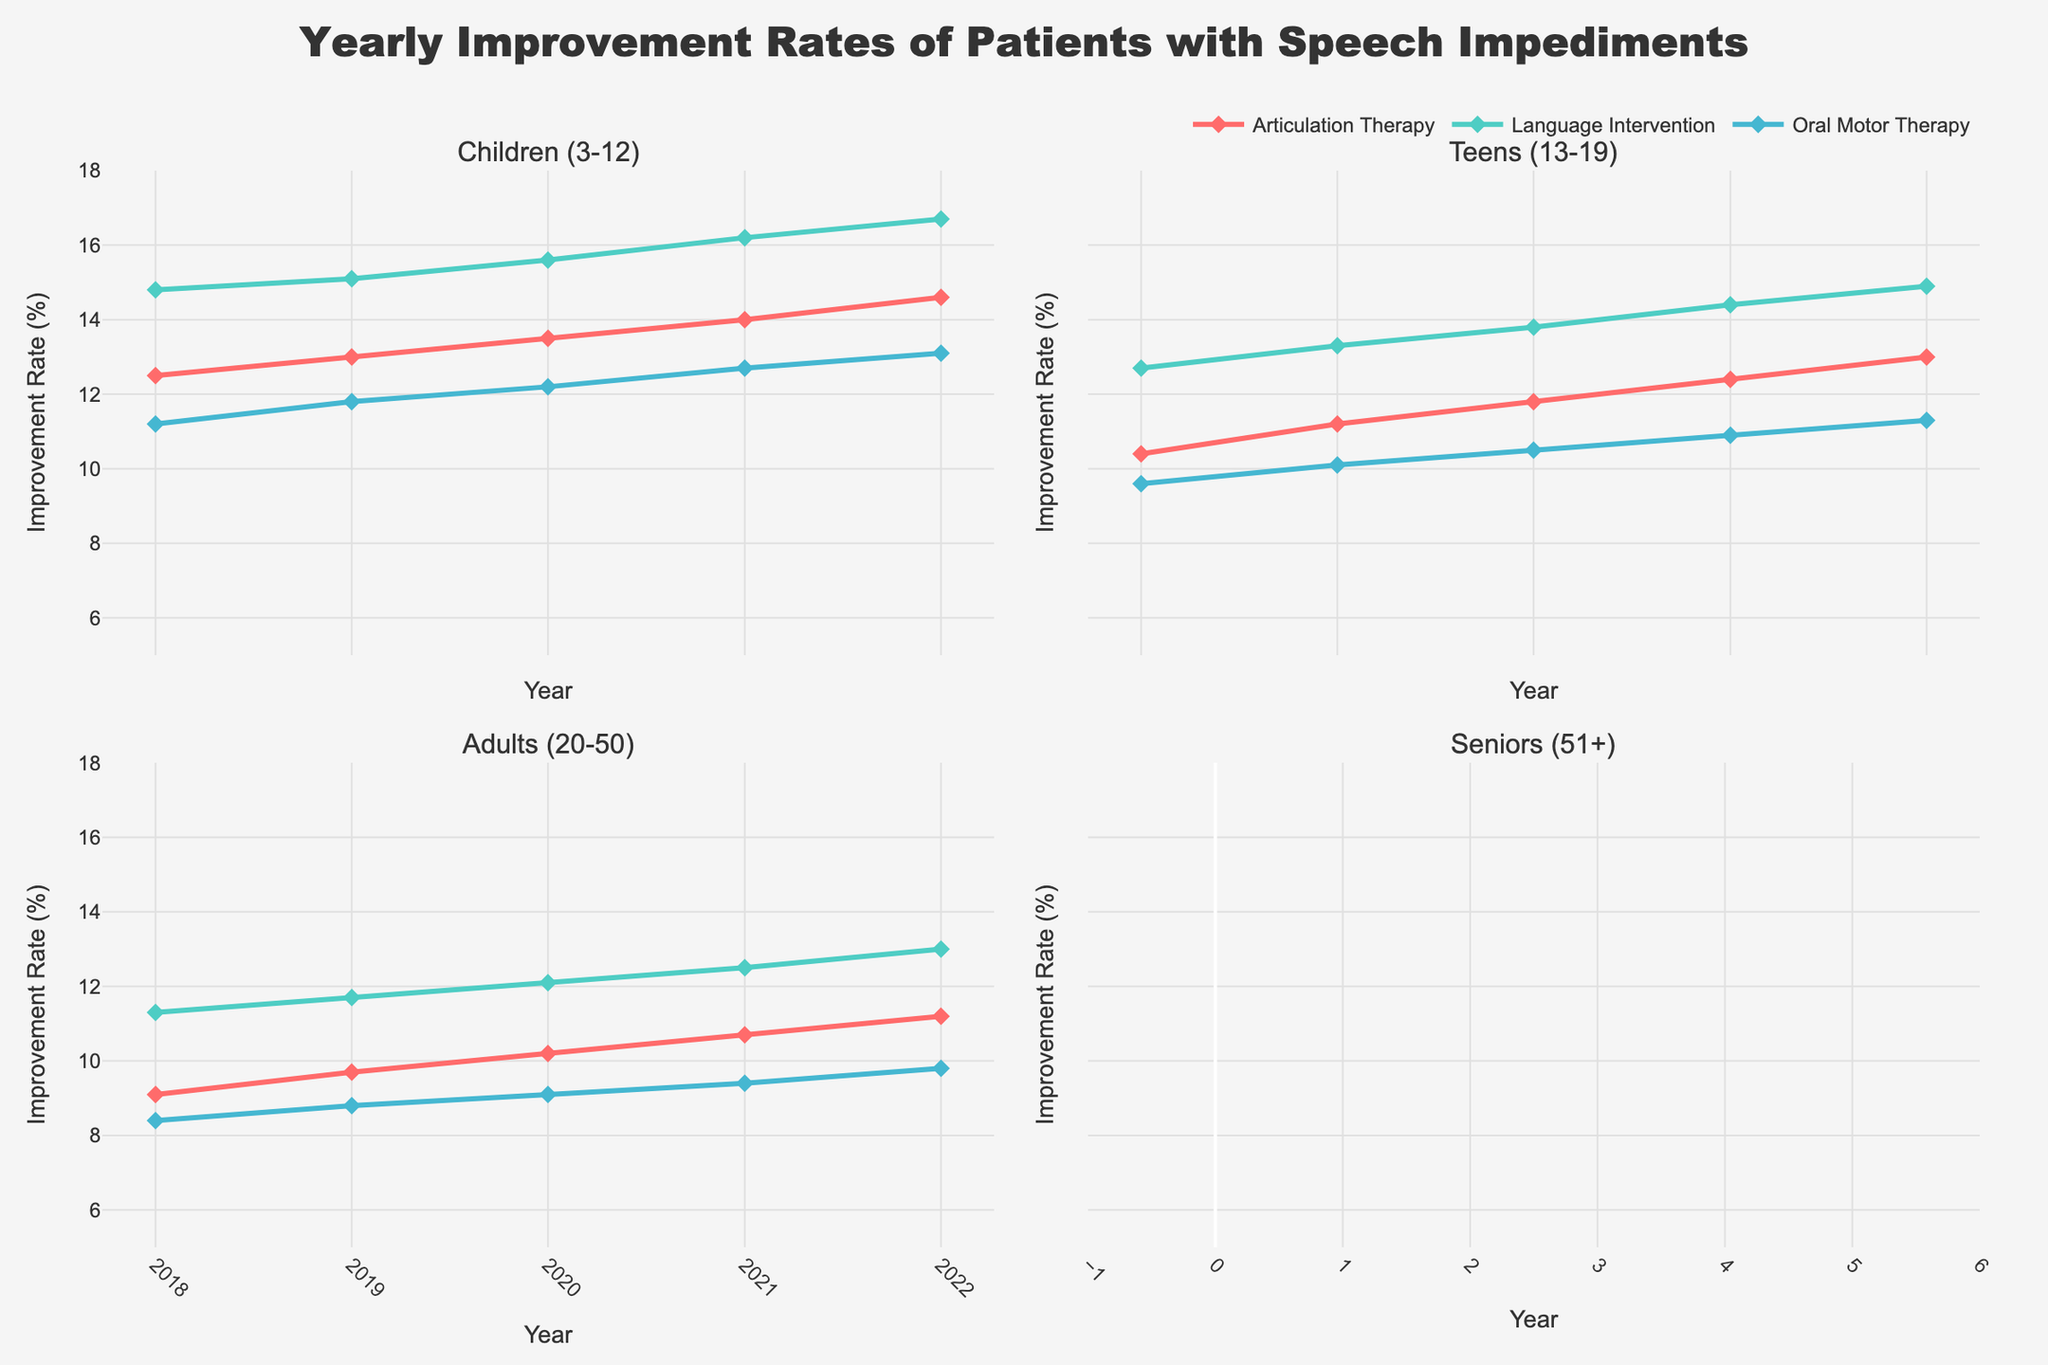What is the title of the figure? The title is located at the top center of the figure. It describes the overall theme of the plot.
Answer: Yearly Improvement Rates of Patients with Speech Impediments What age group shows the highest improvement rate with 'Language Intervention' in 2022? Look at the subplot for each age group in 2022 and identify the line for 'Language Intervention' (color-coded) and its corresponding y-value.
Answer: Children (3-12) Which treatment method shows a constantly increasing improvement rate for 'Teens (13-19)' over the years? Examine the subplot for 'Teens (13-19)' and follow each treatment method's line over different years to determine if there's a steady increase.
Answer: Articulation Therapy For 'Seniors (51+)', how many percentage points did the improvement rate for 'Articulation Therapy' change from 2018 to 2022? In the subplot for 'Seniors (51+)', check the y-values for 'Articulation Therapy' in 2018 and 2022, then calculate the difference.
Answer: 1.8 Which age group and treatment method combination had the lowest improvement rate overall in 2018? Look at each subplot for 2018 and compare the lines of all treatment methods, identifying the minimum y-value.
Answer: Seniors (51+), Oral Motor Therapy Compare the difference in improvement rates between 'Language Intervention' and 'Articulation Therapy' for 'Adults (20-50)' in 2021. Find the y-values for 'Language Intervention' and 'Articulation Therapy' for 'Adults (20-50)' in 2021, then calculate their difference.
Answer: 1.8 Which treatment method had the steepest increase in improvement rates for 'Children (3-12)' from 2018 to 2022? Focus on the 'Children (3-12)' subplot and compare the slopes of the lines for each treatment method, identifying which has the steepest positive slope.
Answer: Language Intervention How does the improvement rate trend for 'Oral Motor Therapy' differ between 'Children (3-12)' and 'Seniors (51+)'? Assess the overall shape of the 'Oral Motor Therapy' lines for both 'Children (3-12)' and 'Seniors (51+)', noting whether the trend is increasing, decreasing, or stable.
Answer: Increasing for Children, Stable for Seniors Which age group shows the most consistent improvement rates across all treatment methods from 2018 to 2022? Look at the trend lines for each age group and treatment method, evaluating their consistency (less fluctuation) across years.
Answer: Adults (20-50) What is the average improvement rate for 'Language Intervention' for 'Teens (13-19)' from 2018 to 2022? List the improvement rates for 'Language Intervention' for 'Teens (13-19)' across these years and calculate the average.
Answer: 13.82 